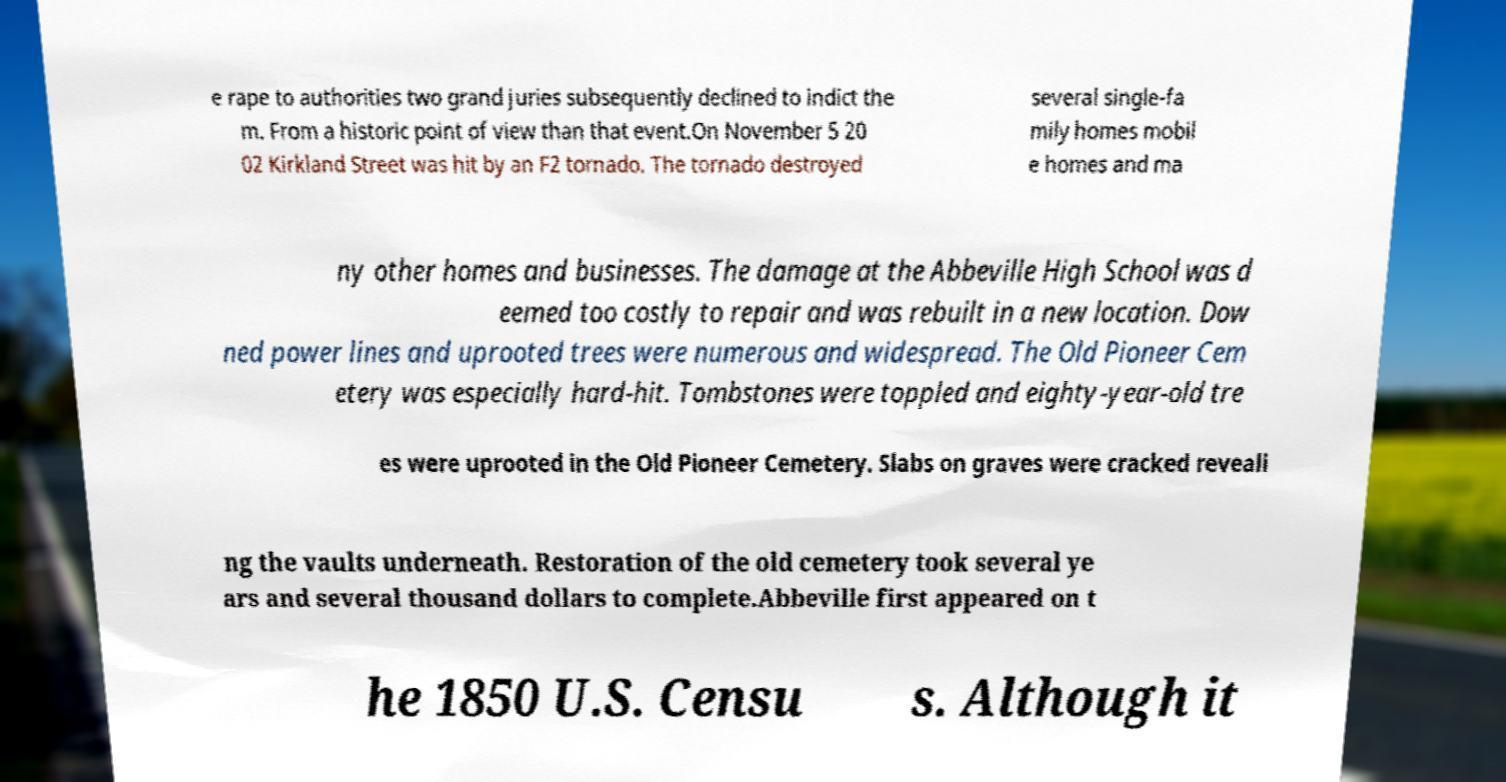Please read and relay the text visible in this image. What does it say? e rape to authorities two grand juries subsequently declined to indict the m. From a historic point of view than that event.On November 5 20 02 Kirkland Street was hit by an F2 tornado. The tornado destroyed several single-fa mily homes mobil e homes and ma ny other homes and businesses. The damage at the Abbeville High School was d eemed too costly to repair and was rebuilt in a new location. Dow ned power lines and uprooted trees were numerous and widespread. The Old Pioneer Cem etery was especially hard-hit. Tombstones were toppled and eighty-year-old tre es were uprooted in the Old Pioneer Cemetery. Slabs on graves were cracked reveali ng the vaults underneath. Restoration of the old cemetery took several ye ars and several thousand dollars to complete.Abbeville first appeared on t he 1850 U.S. Censu s. Although it 